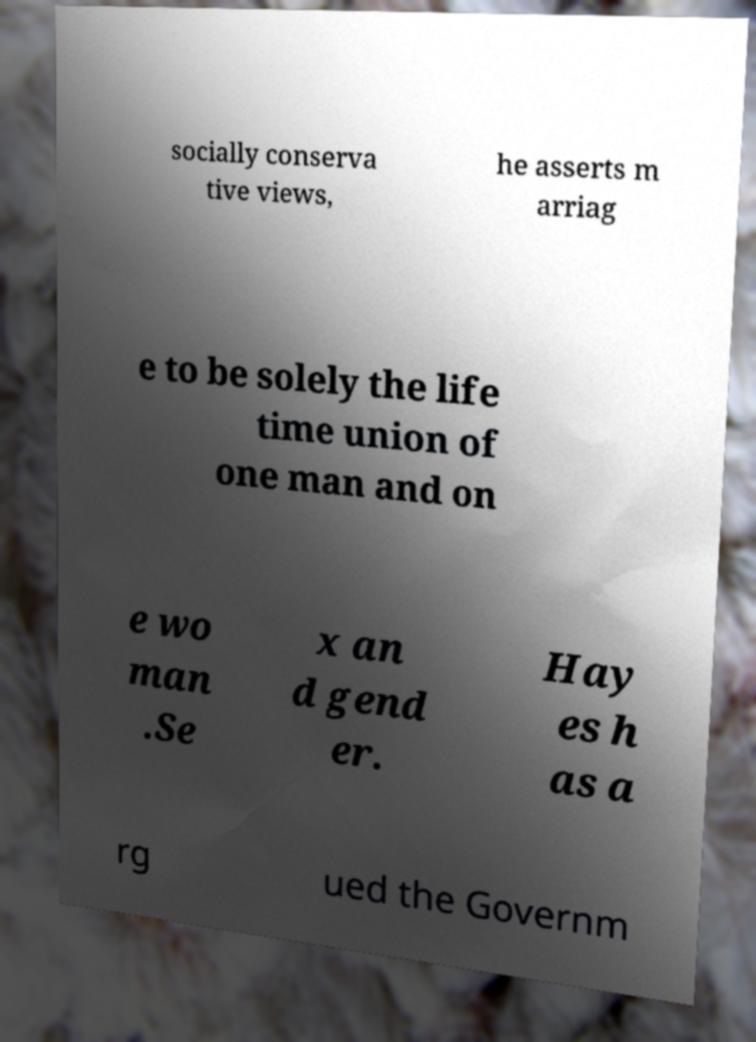Could you assist in decoding the text presented in this image and type it out clearly? socially conserva tive views, he asserts m arriag e to be solely the life time union of one man and on e wo man .Se x an d gend er. Hay es h as a rg ued the Governm 